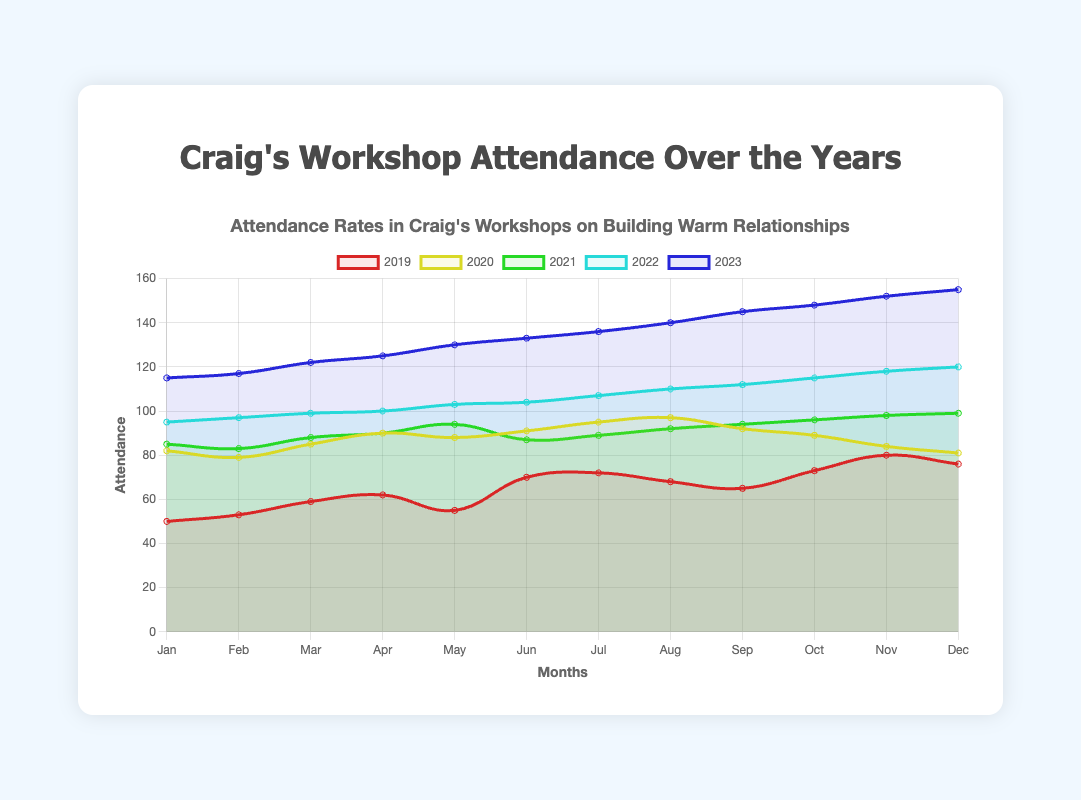Which year had the highest attendance in December? To find this, one must look at the December data points across all the years and compare their values. December attendance values are: 76 (2019), 81 (2020), 99 (2021), 120 (2022), and 155 (2023). The highest value is 155 in 2023.
Answer: 2023 What's the average attendance in Craig's workshops in 2021? Sum the monthly attendance values of 2021 and divide by 12. The attendance values for 2021 are: 85, 83, 88, 90, 94, 87, 89, 92, 94, 96, 98, 99. Sum: (85+83+88+90+94+87+89+92+94+96+98+99) = 1095. Average: 1095/12 = 91.25
Answer: 91.25 By how much did attendance increase from January to July in 2020? Note the attendance in January 2020 was 82 and in July 2020 was 95. The difference is 95 - 82 = 13.
Answer: 13 In which year did the attendance show the most consistent growth throughout the year? Consistent growth would show a steady increase each month without sharp drops. By visually inspecting the trends, 2023 exhibits a steady and consistent increase every month.
Answer: 2023 How much higher was the average attendance in 2023 compared to 2019? Calculate the average attendance for 2019 and 2023 first. 2019 values: (50+53+59+62+55+70+72+68+65+73+80+76) = 783/12 = 65.25. 2023 values: (115, 117, 122, 125, 130, 133, 136, 140, 145, 148, 152, 155) = 1618/12 = 134.83. Difference: 134.83 - 65.25 = 69.58
Answer: 69.58 Which months saw the highest attendance across all years tracked? Review each month across the years and identify the maximum value for each month. The highest attendance for each month appears to be in 2023: January (115), February (117), March (122), and so on. Hence, every month saw the highest value in 2023.
Answer: 2023 